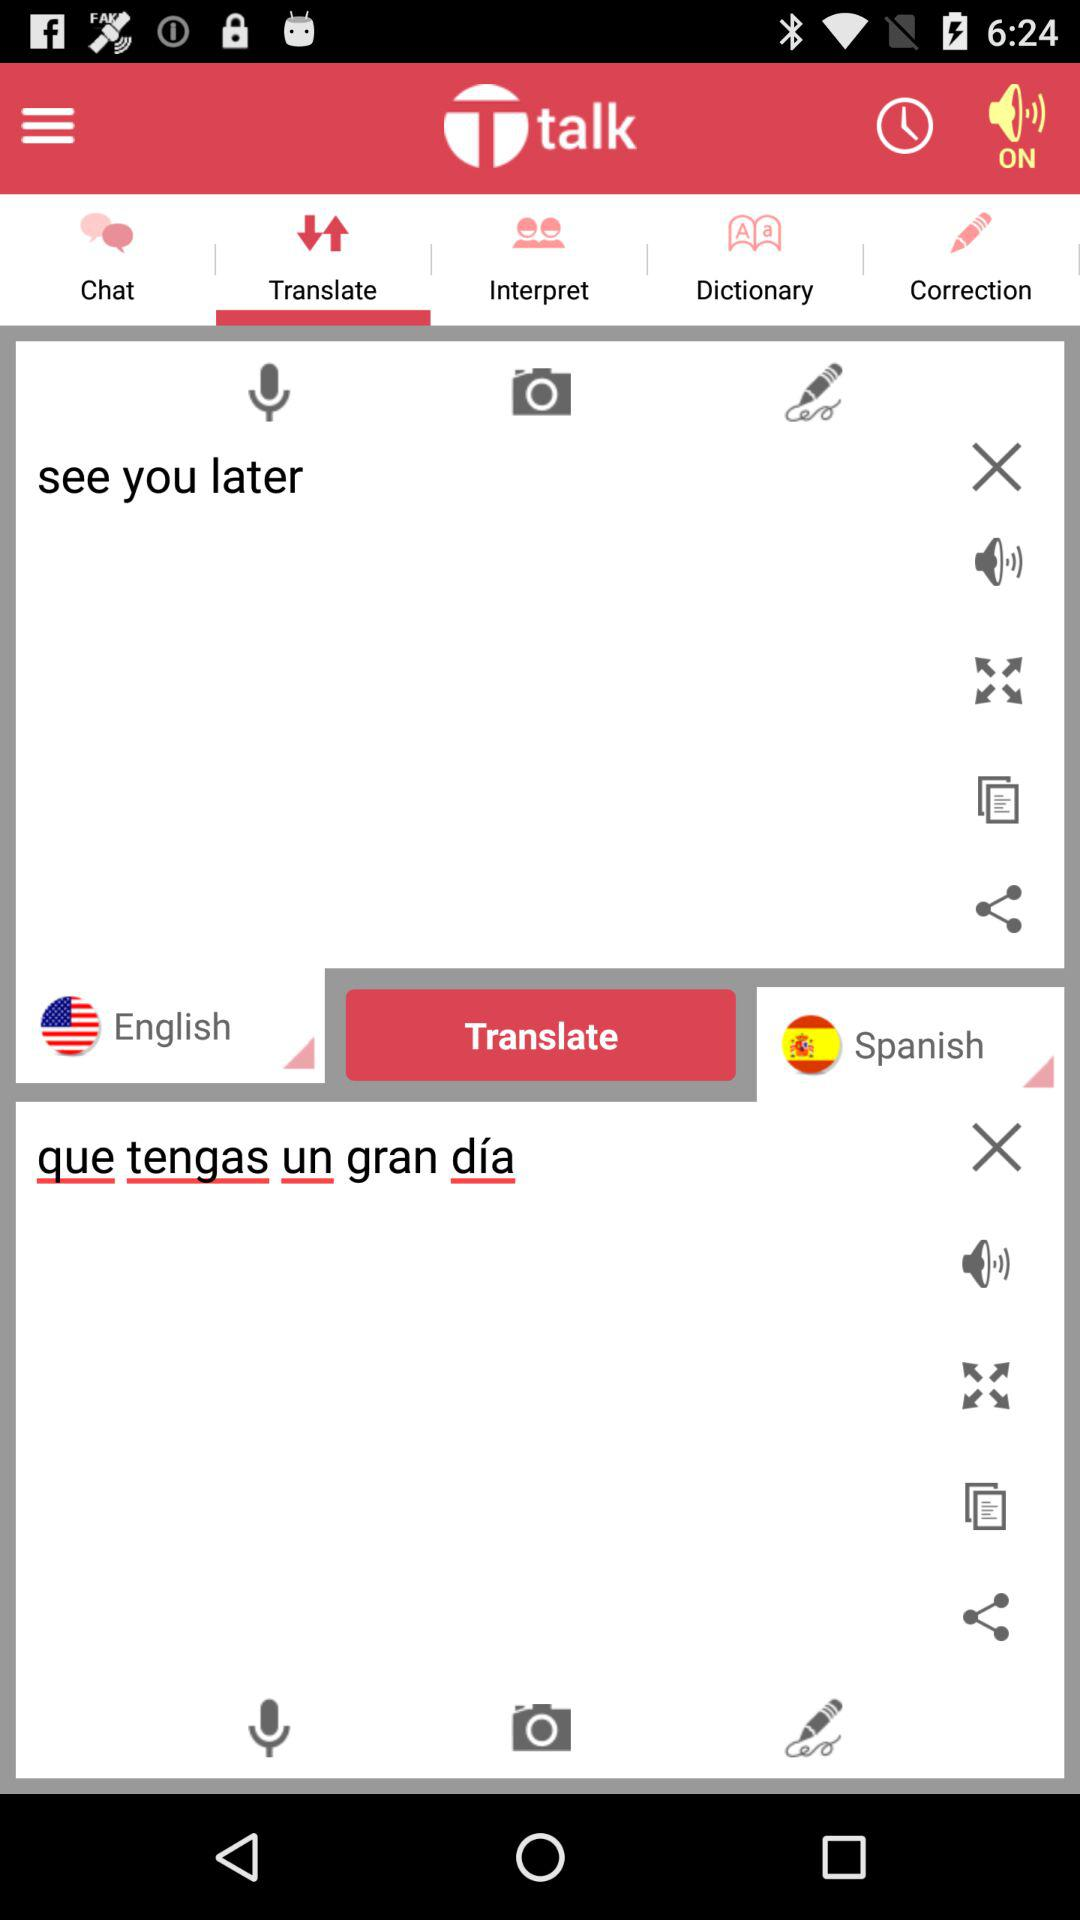Is it morning or evening?
When the provided information is insufficient, respond with <no answer>. <no answer> 